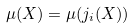<formula> <loc_0><loc_0><loc_500><loc_500>\mu ( X ) = \mu ( j _ { i } ( X ) )</formula> 